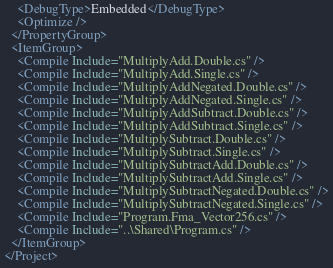<code> <loc_0><loc_0><loc_500><loc_500><_XML_>    <DebugType>Embedded</DebugType>
    <Optimize />
  </PropertyGroup>
  <ItemGroup>
    <Compile Include="MultiplyAdd.Double.cs" />
    <Compile Include="MultiplyAdd.Single.cs" />
    <Compile Include="MultiplyAddNegated.Double.cs" />
    <Compile Include="MultiplyAddNegated.Single.cs" />
    <Compile Include="MultiplyAddSubtract.Double.cs" />
    <Compile Include="MultiplyAddSubtract.Single.cs" />
    <Compile Include="MultiplySubtract.Double.cs" />
    <Compile Include="MultiplySubtract.Single.cs" />
    <Compile Include="MultiplySubtractAdd.Double.cs" />
    <Compile Include="MultiplySubtractAdd.Single.cs" />
    <Compile Include="MultiplySubtractNegated.Double.cs" />
    <Compile Include="MultiplySubtractNegated.Single.cs" />
    <Compile Include="Program.Fma_Vector256.cs" />
    <Compile Include="..\Shared\Program.cs" />
  </ItemGroup>
</Project>
</code> 